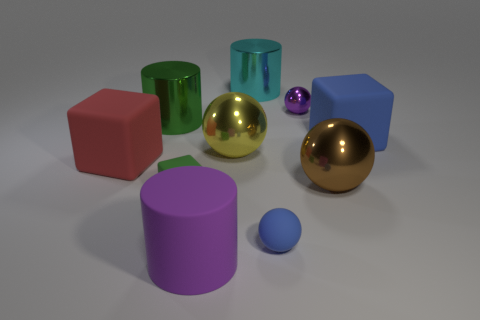Is the number of large brown objects that are behind the big cyan thing greater than the number of big red matte things in front of the small green rubber thing? Upon examining the image, it is evident that there are no large brown objects behind the big cyan cylinder, and there are no big red matte objects in front of the small green cylinder. Therefore, the answer is no, as the quantities for comparison in the question are nonexistent. 